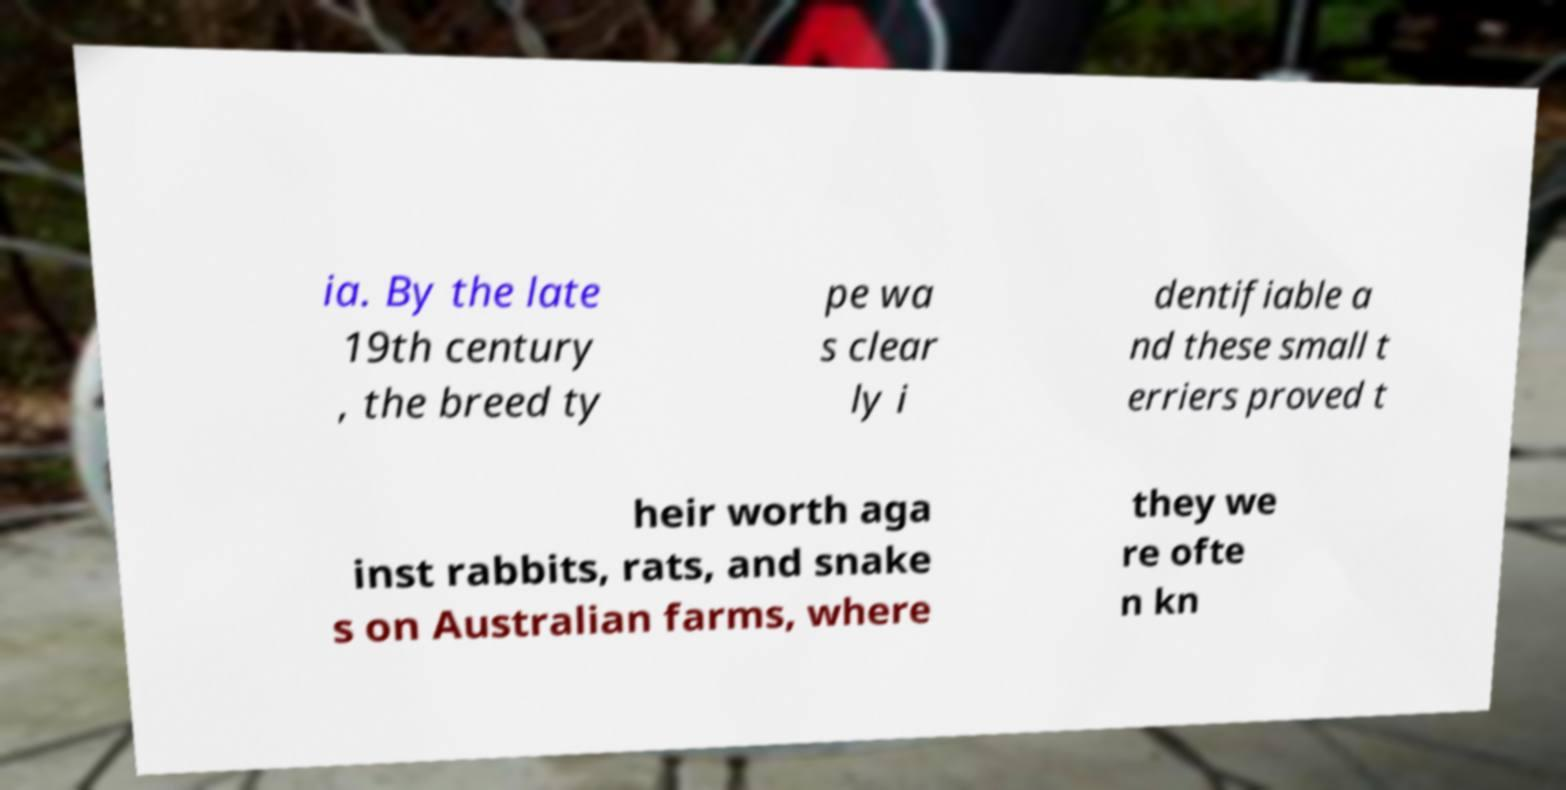Can you accurately transcribe the text from the provided image for me? ia. By the late 19th century , the breed ty pe wa s clear ly i dentifiable a nd these small t erriers proved t heir worth aga inst rabbits, rats, and snake s on Australian farms, where they we re ofte n kn 